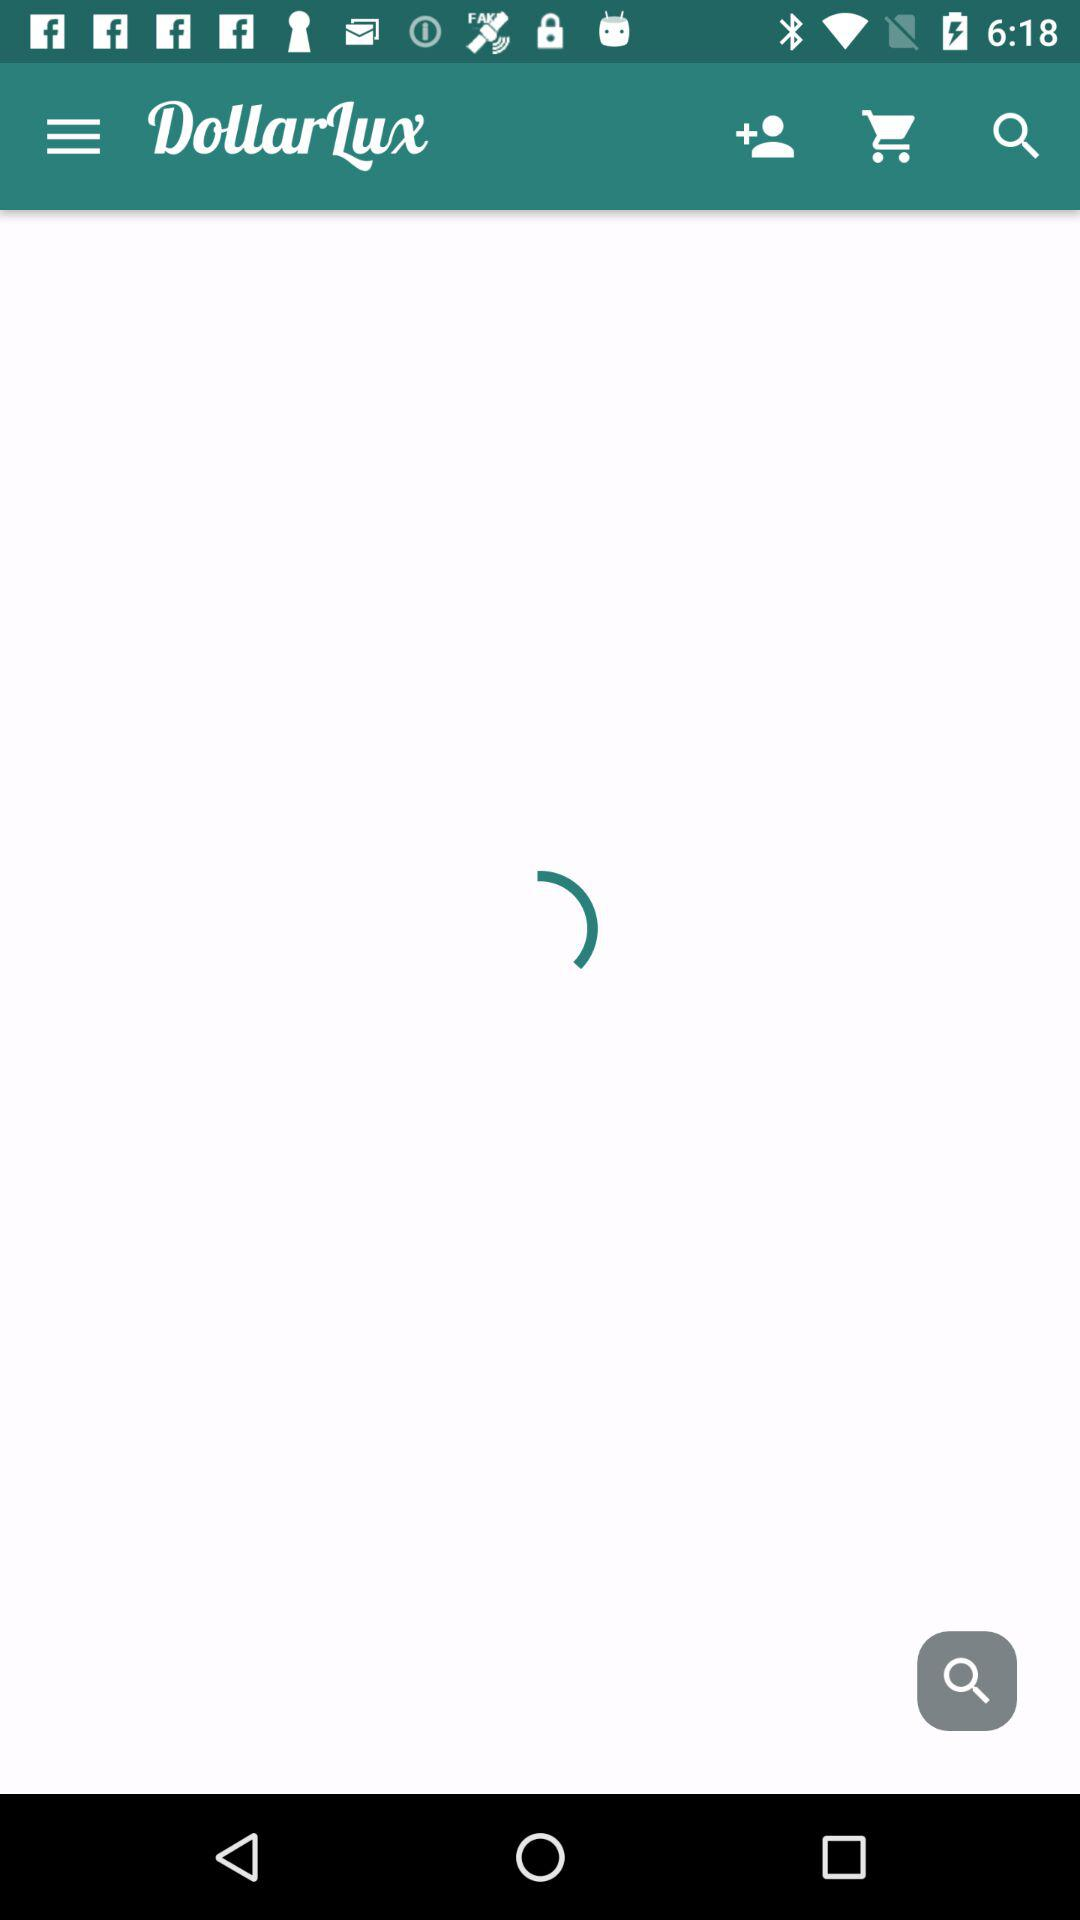How many people are on the account?
When the provided information is insufficient, respond with <no answer>. <no answer> 